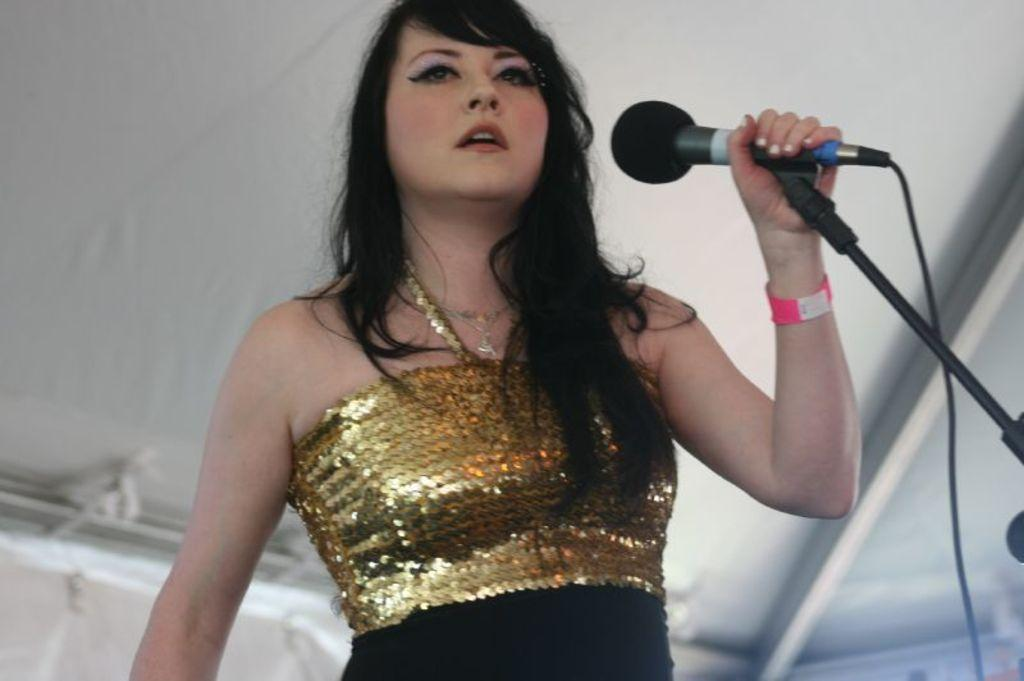Who is the main subject in the image? There is a lady person in the image. What is the lady person wearing? The lady person is wearing a golden color dress. What is the lady person holding in her hand? The lady person is holding a microphone in her left hand. What can be seen in the background of the image? There is a white color sheet in the background of the image. Can you see any stones or rocks near the lady person in the image? There are no stones or rocks visible in the image; it features a lady person wearing a golden color dress, holding a microphone, and standing in front of a white color sheet. 